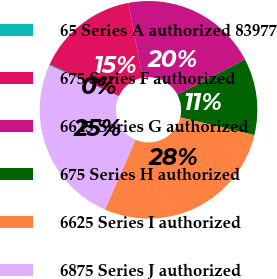Convert chart. <chart><loc_0><loc_0><loc_500><loc_500><pie_chart><fcel>65 Series A authorized 83977<fcel>675 Series F authorized<fcel>6625 Series G authorized<fcel>675 Series H authorized<fcel>6625 Series I authorized<fcel>6875 Series J authorized<nl><fcel>0.18%<fcel>15.2%<fcel>20.29%<fcel>11.4%<fcel>27.83%<fcel>25.09%<nl></chart> 